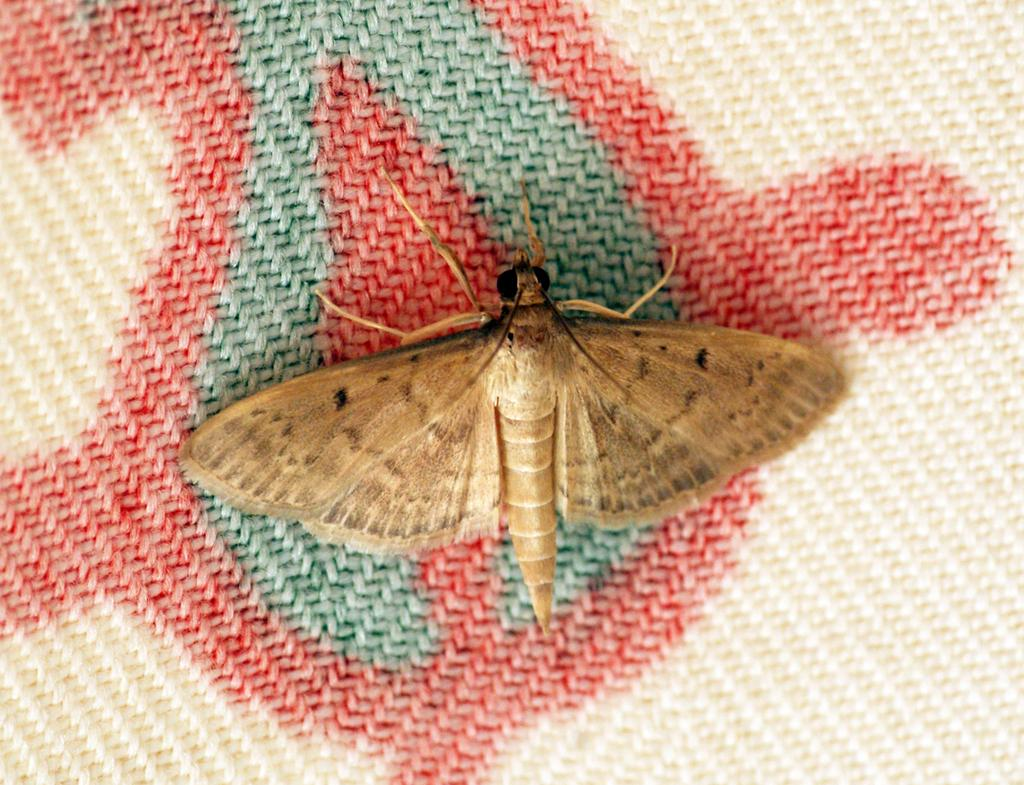What type of insect is present in the image? There is a moth in the picture. What is located at the bottom of the image? There is a cloth at the bottom of the picture. How far is the distance between the moth and the cloth in the image? The distance between the moth and the cloth cannot be determined from the image, as there is no reference point or scale provided. 